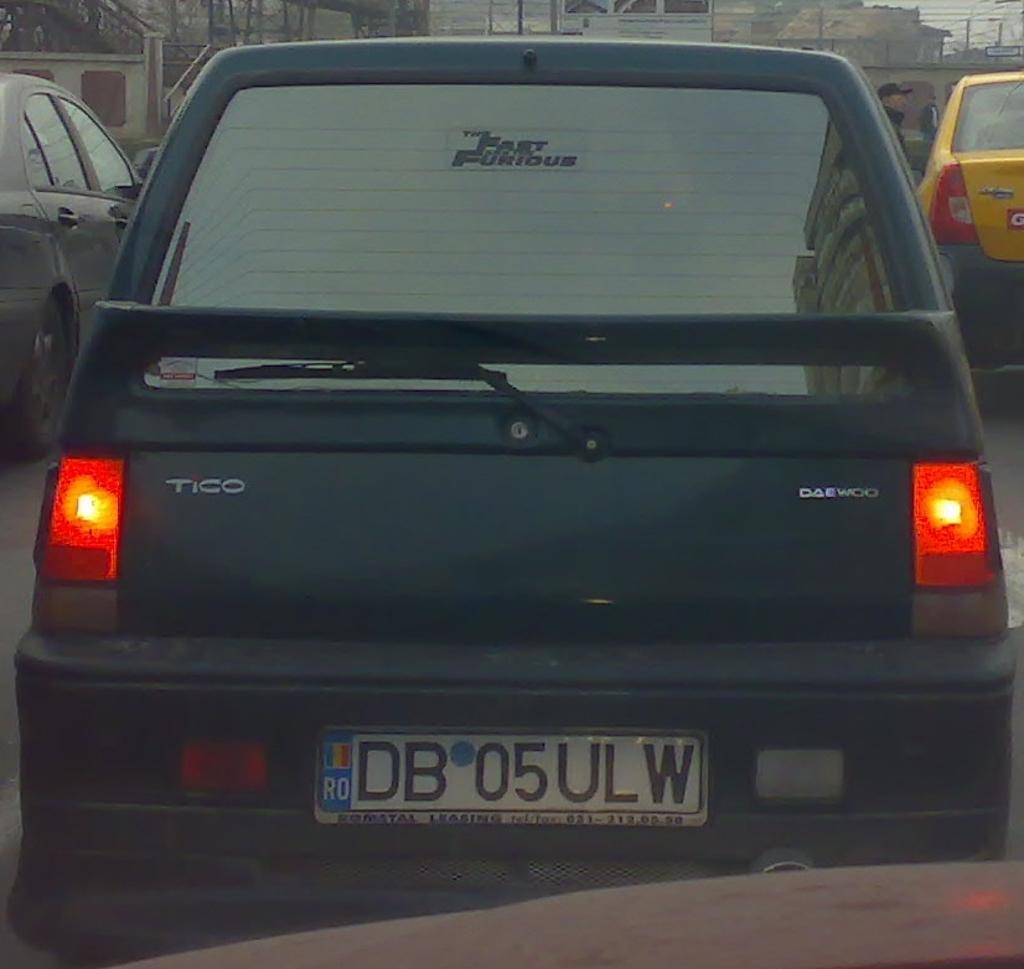<image>
Offer a succinct explanation of the picture presented. The back of a tico that is sitting in traffic with brake lights on. 